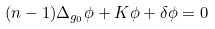<formula> <loc_0><loc_0><loc_500><loc_500>( n - 1 ) \Delta _ { g _ { 0 } } \phi + K \phi + \delta \phi = 0</formula> 